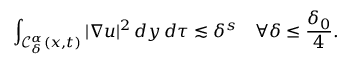Convert formula to latex. <formula><loc_0><loc_0><loc_500><loc_500>\int _ { \mathcal { C } _ { \delta } ^ { \alpha } ( x , t ) } | \nabla u | ^ { 2 } \, d y \, d \tau \lesssim \delta ^ { s } \quad \forall \delta \leq \frac { \delta _ { 0 } } { 4 } .</formula> 